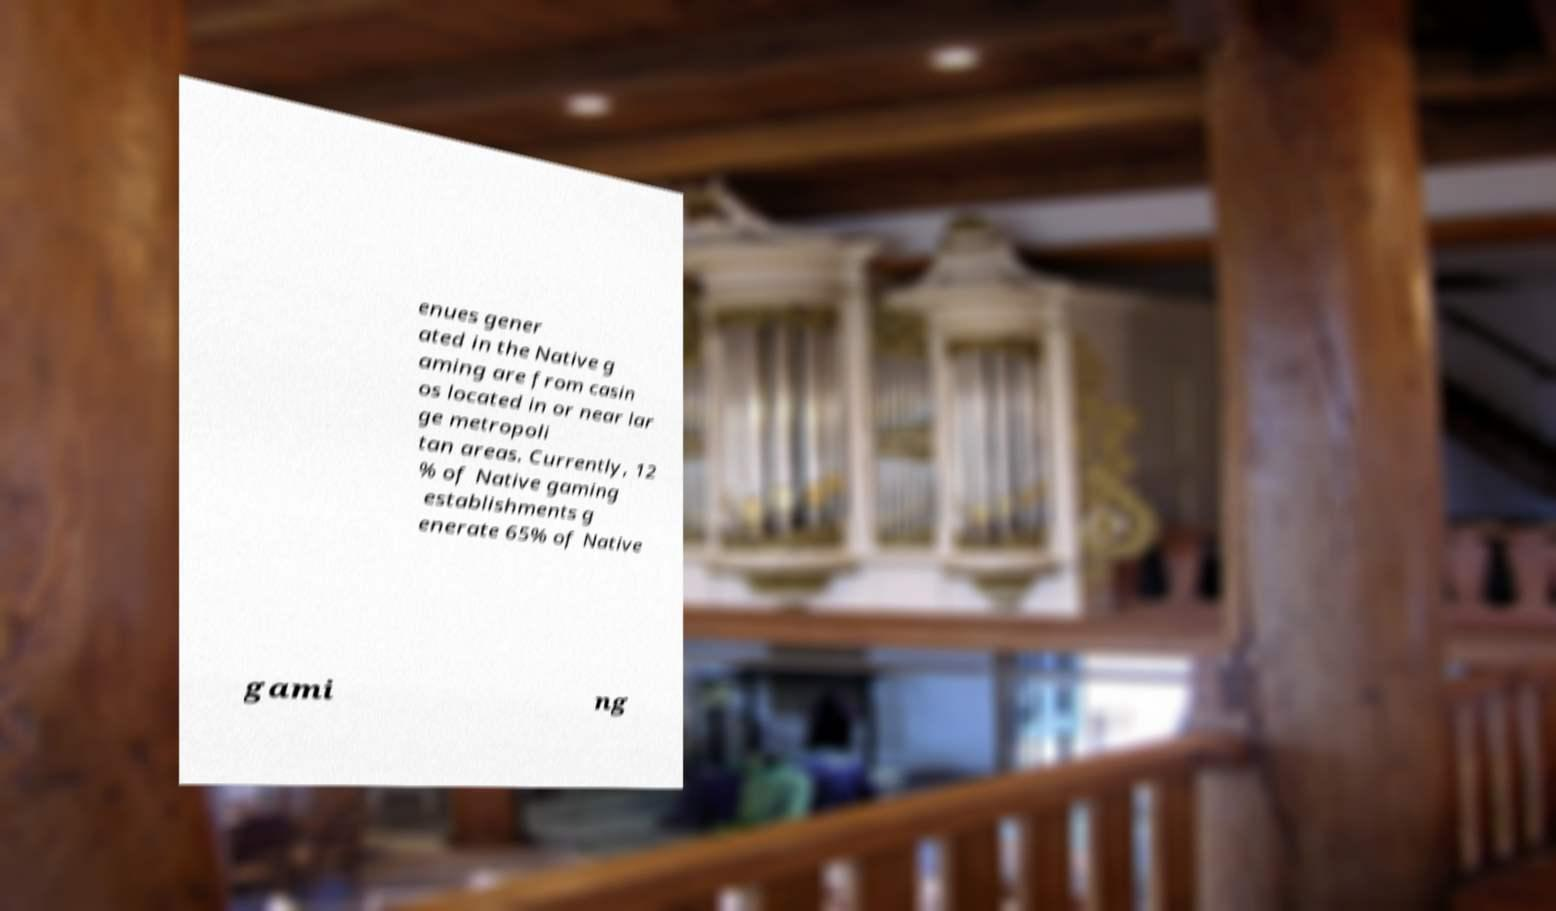For documentation purposes, I need the text within this image transcribed. Could you provide that? enues gener ated in the Native g aming are from casin os located in or near lar ge metropoli tan areas. Currently, 12 % of Native gaming establishments g enerate 65% of Native gami ng 